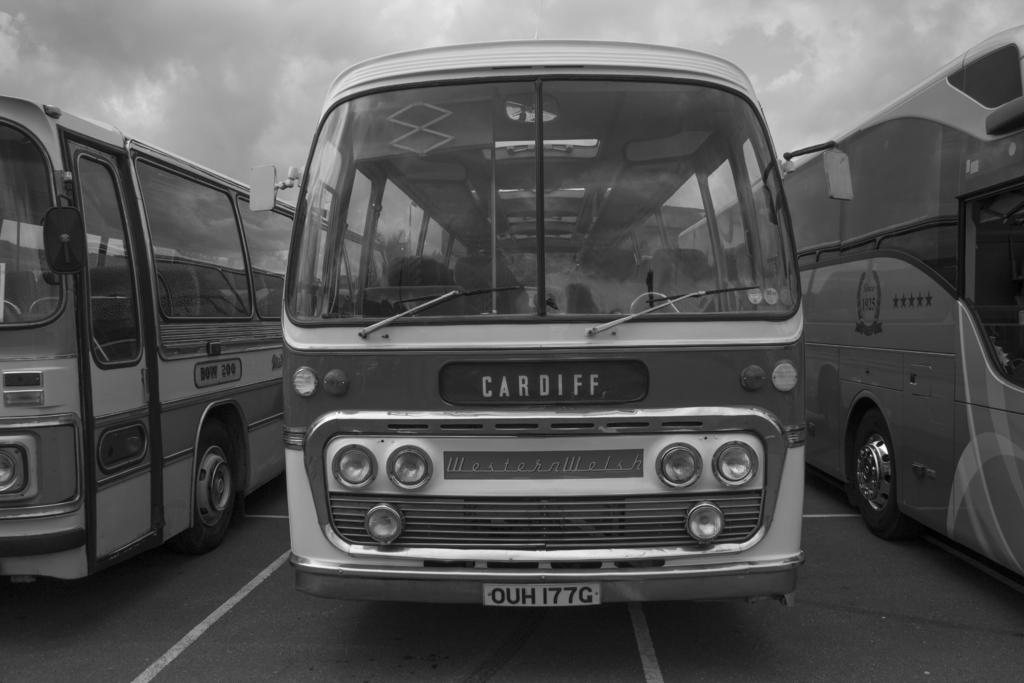What does the license plate say?
Provide a short and direct response. Ouh177g. What is the word in the middle of the front of this bus?
Offer a terse response. Cardiff. 